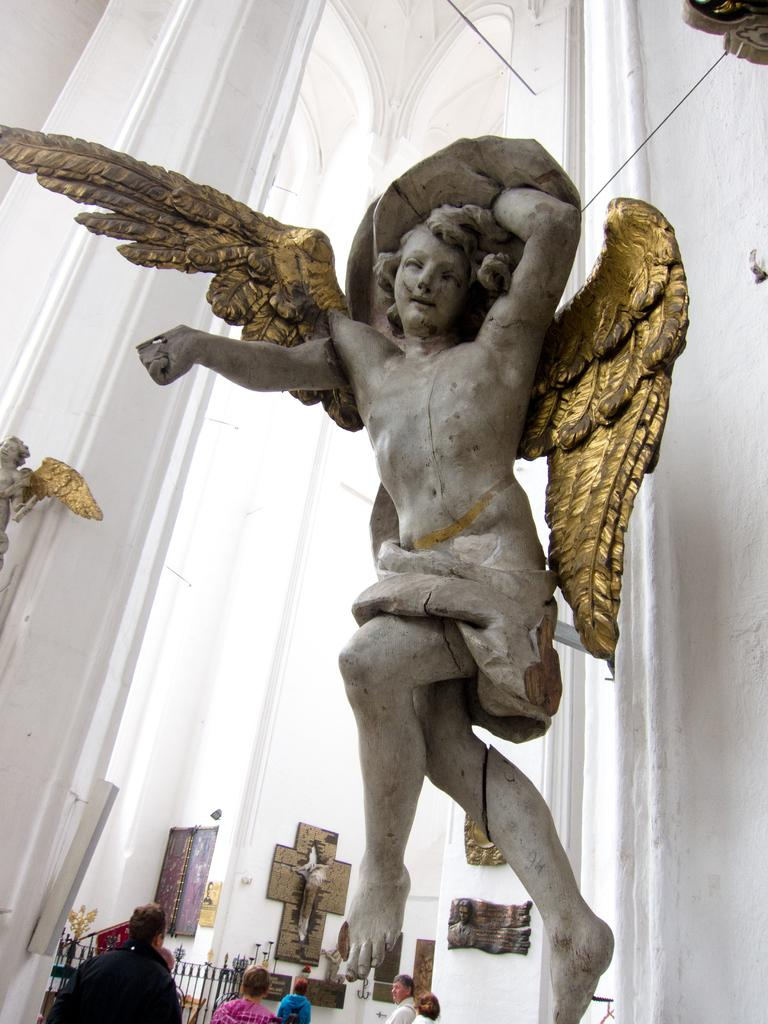What type of statues can be seen in the image? There are statues of an angel in the image. What is on the wall in the image? There are objects on the wall in the image. Can you describe the background of the image? There are people in the background of the image. What type of mark can be seen on the angel's statue in the image? There is no mark visible on the angel's statue in the image. What reward is being given to the people in the background of the image? There is no indication of a reward being given to the people in the background of the image. 